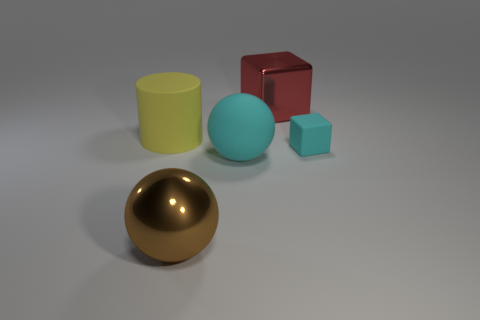What materials do the objects in the image seem to be made of? The sphere appears to have a reflective surface similar to polished metal, while the cube and the small cube look like they have a matte finish, possibly plastic. The cylinder and the sphere in the back seem to have a slightly matte or rubbery texture. Can you provide color descriptions for these objects? Certainly! The sphere has a gold tone, the large cube is red, the smaller cube is a light blue, the cylinder is yellow, and the sphere in the back is teal. 